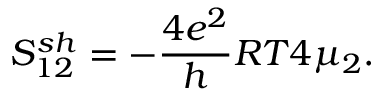Convert formula to latex. <formula><loc_0><loc_0><loc_500><loc_500>{ S _ { 1 2 } ^ { s h } = - \frac { 4 e ^ { 2 } } { h } R T 4 \mu _ { 2 } } .</formula> 